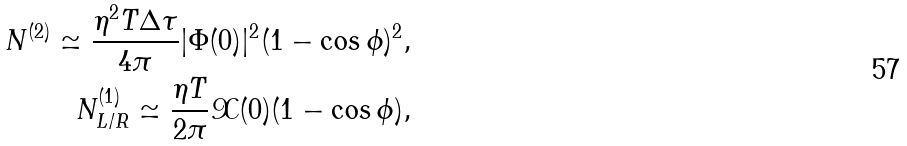Convert formula to latex. <formula><loc_0><loc_0><loc_500><loc_500>N ^ { ( 2 ) } \simeq \frac { \eta ^ { 2 } T \Delta \tau } { 4 \pi } | \Phi ( 0 ) | ^ { 2 } ( 1 - \cos \phi ) ^ { 2 } , \\ N _ { L / R } ^ { ( 1 ) } \simeq \frac { \eta T } { 2 \pi } \mathcal { X } ( 0 ) ( 1 - \cos \phi ) ,</formula> 